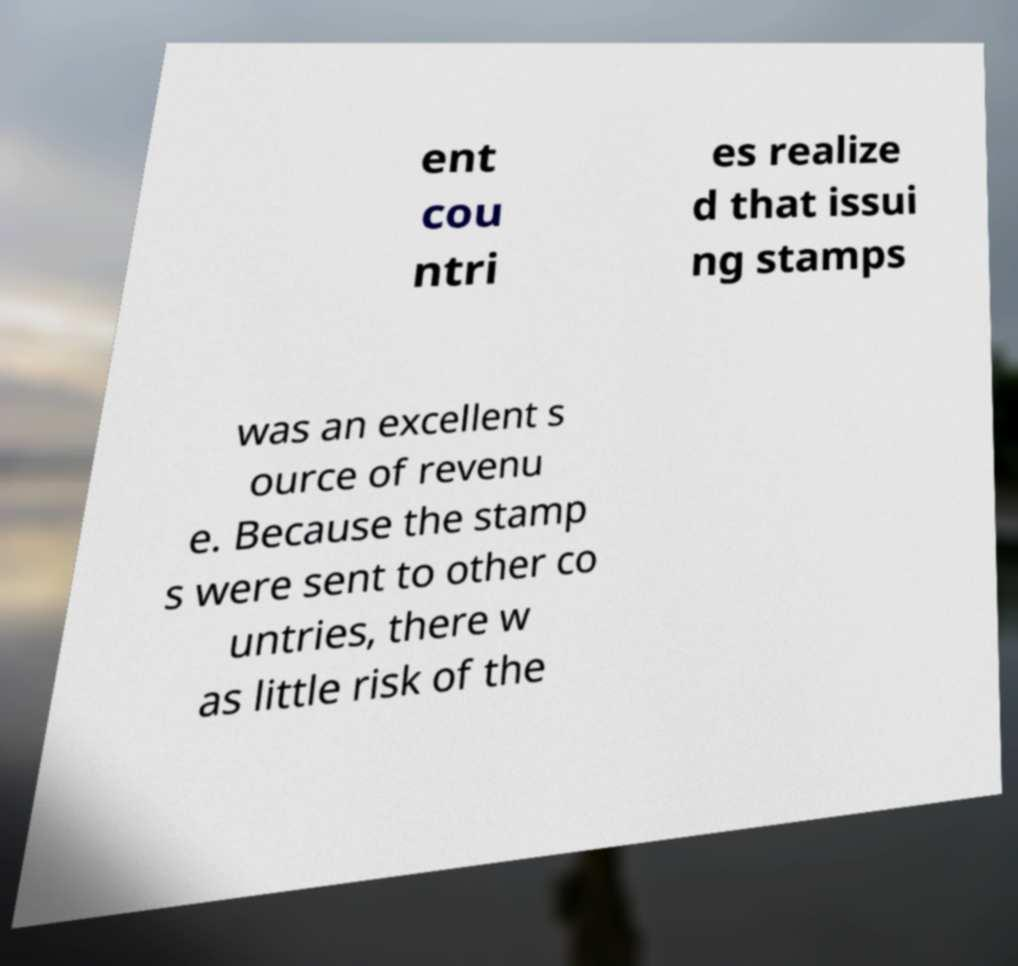Could you extract and type out the text from this image? ent cou ntri es realize d that issui ng stamps was an excellent s ource of revenu e. Because the stamp s were sent to other co untries, there w as little risk of the 